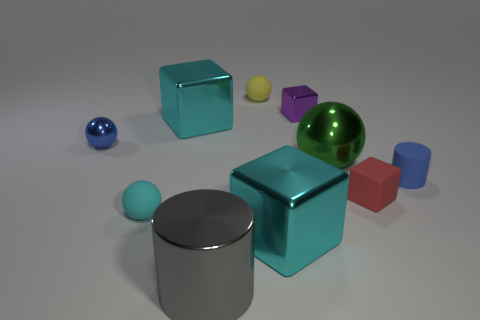The big metallic object in front of the large cyan metal object in front of the small blue matte thing is what color?
Offer a very short reply. Gray. There is a yellow object that is the same size as the red rubber object; what is it made of?
Ensure brevity in your answer.  Rubber. How many metal objects are either cyan balls or small purple cylinders?
Offer a terse response. 0. There is a tiny object that is behind the tiny red matte object and on the right side of the green metal object; what is its color?
Make the answer very short. Blue. There is a tiny matte cube; how many small things are to the right of it?
Your answer should be compact. 1. What material is the blue cylinder?
Your answer should be very brief. Rubber. There is a tiny rubber cylinder that is behind the tiny rubber sphere left of the small rubber ball behind the large green metallic thing; what is its color?
Your answer should be compact. Blue. How many shiny balls have the same size as the red thing?
Your answer should be compact. 1. What is the color of the small rubber object that is on the left side of the big gray thing?
Your answer should be compact. Cyan. What number of other objects are the same size as the blue matte thing?
Ensure brevity in your answer.  5. 